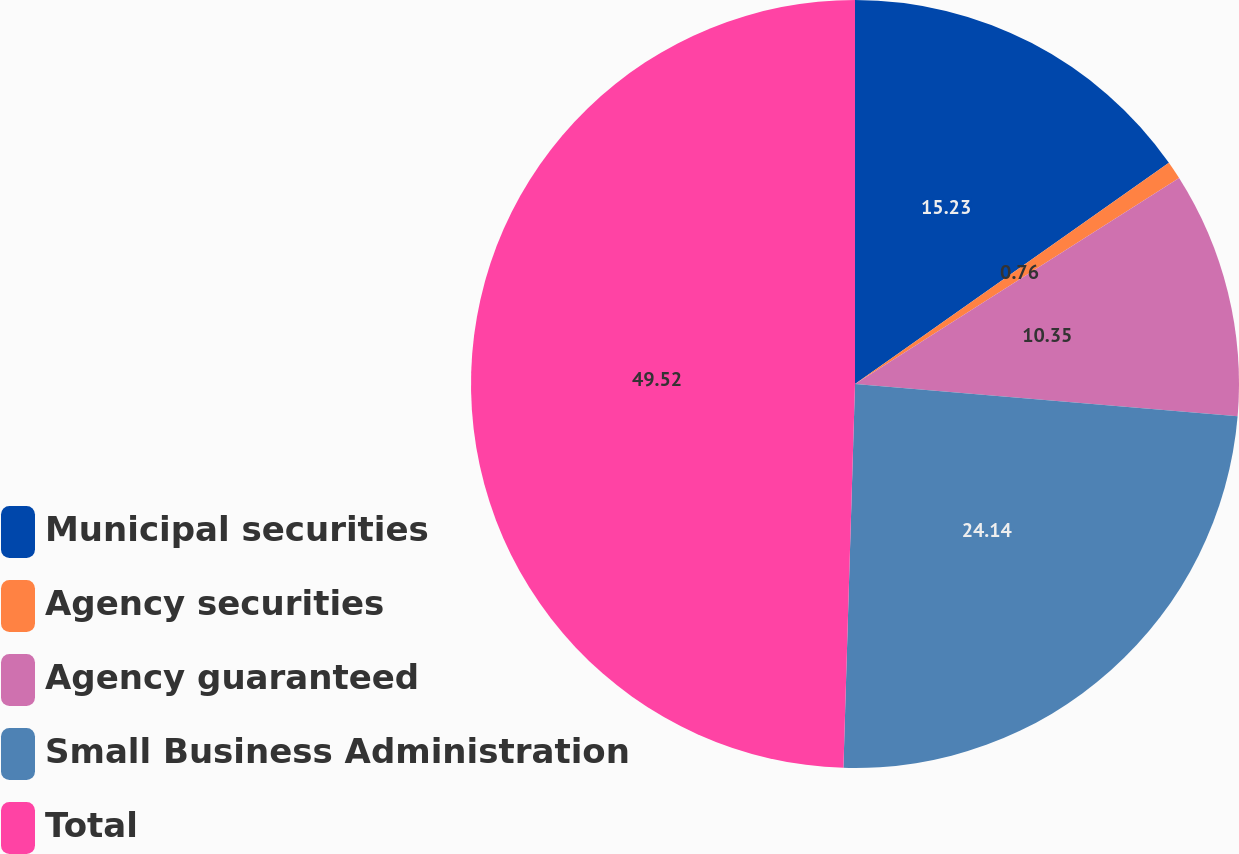<chart> <loc_0><loc_0><loc_500><loc_500><pie_chart><fcel>Municipal securities<fcel>Agency securities<fcel>Agency guaranteed<fcel>Small Business Administration<fcel>Total<nl><fcel>15.23%<fcel>0.76%<fcel>10.35%<fcel>24.14%<fcel>49.52%<nl></chart> 